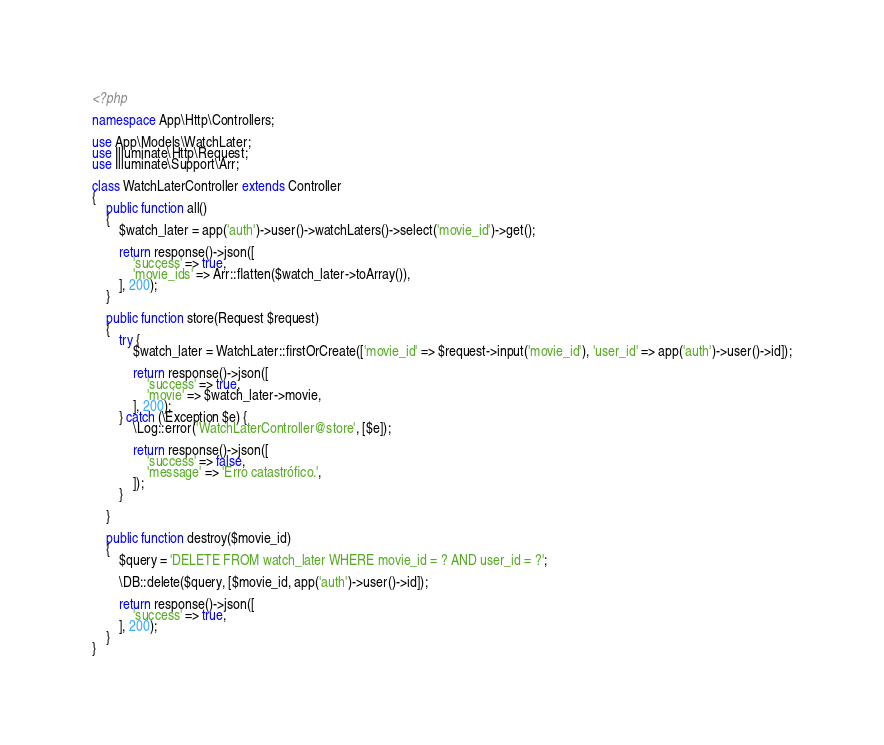<code> <loc_0><loc_0><loc_500><loc_500><_PHP_><?php

namespace App\Http\Controllers;

use App\Models\WatchLater;
use Illuminate\Http\Request;
use Illuminate\Support\Arr;

class WatchLaterController extends Controller
{
    public function all()
    {
        $watch_later = app('auth')->user()->watchLaters()->select('movie_id')->get();

        return response()->json([
            'success' => true,
            'movie_ids' => Arr::flatten($watch_later->toArray()),
        ], 200);
    }

    public function store(Request $request)
    {
        try {
            $watch_later = WatchLater::firstOrCreate(['movie_id' => $request->input('movie_id'), 'user_id' => app('auth')->user()->id]);

            return response()->json([
                'success' => true,
                'movie' => $watch_later->movie,
            ], 200);
        } catch (\Exception $e) {
            \Log::error('WatchLaterController@store', [$e]);

            return response()->json([
                'success' => false,
                'message' => 'Erro catastrófico.',
            ]);
        }

    }

    public function destroy($movie_id)
    {
        $query = 'DELETE FROM watch_later WHERE movie_id = ? AND user_id = ?';

        \DB::delete($query, [$movie_id, app('auth')->user()->id]);

        return response()->json([
            'success' => true,
        ], 200);
    }
}</code> 